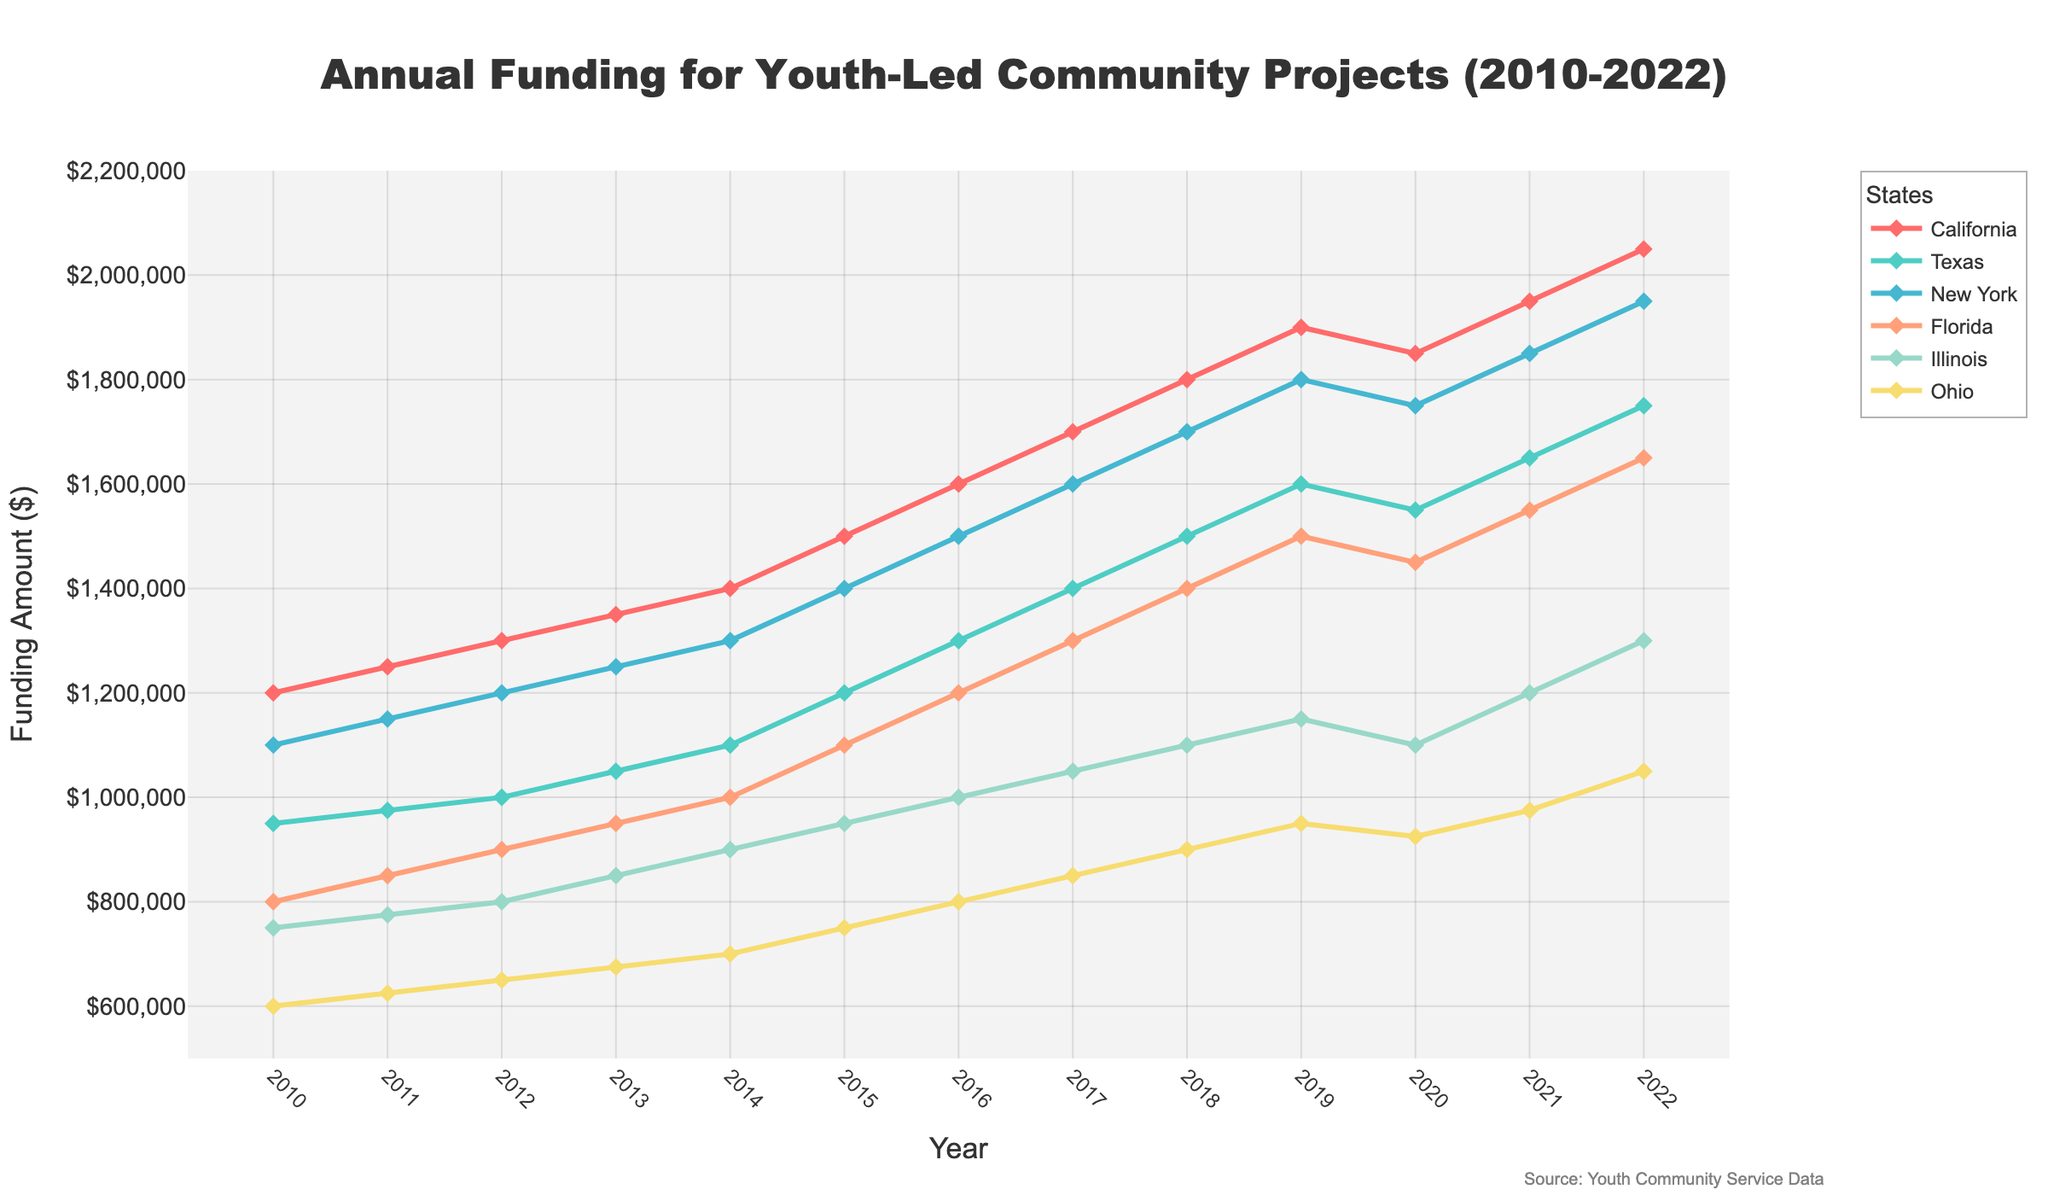What is the trend of funding in California from 2010 to 2022? The funding in California shows a consistent upward trend from 2010 to 2022. Each year, the allocated amount increases steadily. For example, starting from $1,200,000 in 2010, it reaches $2,050,000 in 2022.
Answer: The trend is consistently upward Which state had the highest funding in 2015? By looking at the data points for 2015, California had the highest funding amount at $1,500,000. Other states had lower amounts comparatively (Texas $1,200,000, New York $1,400,000, etc.).
Answer: California How did the funding for Ohio change between 2020 and 2022? The funding for Ohio increased from $925,000 in 2020 to $975,000 in 2021, and then to $1,050,000 in 2022. There is a clear upward trend in funding over these years.
Answer: It increased Among Texas and New York, which state received more funding in 2018? In 2018, Texas received $1,500,000, whereas New York received $1,700,000. New York received more funding.
Answer: New York Calculate the average funding across all states for the year 2022. Summing the 2022 funding values for all states: 2,050,000 (California) + 1,750,000 (Texas) + 1,950,000 (New York) + 1,650,000 (Florida) + 1,300,000 (Illinois) + 1,050,000 (Ohio) = 9,750,000. Dividing by the number of states (6): 9,750,000 / 6 = 1,625,000.
Answer: $1,625,000 In which year did Florida reach its funding peak and what was the amount? Florida reached its funding peak in 2022 with an amount of $1,650,000. Before this year, funding continuously increased, reaching its highest in 2022.
Answer: 2022 and $1,650,000 Compare the funding for Illinois in 2011 and 2021. What was the change in the absolute value? In 2011, Illinois received $775,000 and in 2021 it received $1,200,000. The change in absolute value is 1,200,000 - 775,000 = 425,000.
Answer: $425,000 increase Which state experienced the smallest increase in funding from 2010 to 2022? Ohio's funding increased from $600,000 in 2010 to $1,050,000 in 2022, an increase of $450,000. This is the smallest increase compared to other states.
Answer: Ohio What is the difference in funding between New York and Florida in 2019? In 2019, New York received $1,800,000, and Florida received $1,500,000. The difference is 1,800,000 - 1,500,000 = 300,000.
Answer: $300,000 Which state consistently showed an upward trend in funding every year without any decrease from 2010 to 2022? California showed a consistent upward trend every year from 2010 to 2022 without any decrease in funding. Other states had slight variations over the years.
Answer: California 